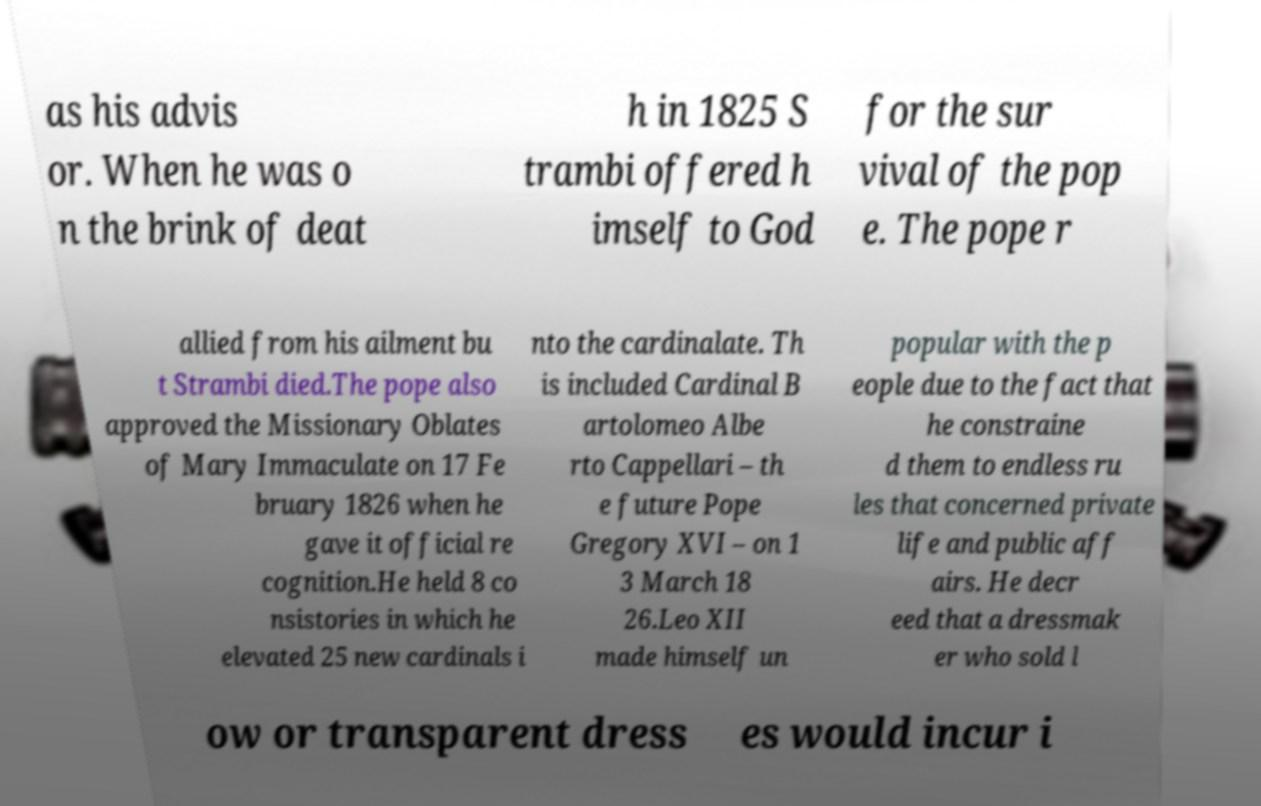Can you read and provide the text displayed in the image?This photo seems to have some interesting text. Can you extract and type it out for me? as his advis or. When he was o n the brink of deat h in 1825 S trambi offered h imself to God for the sur vival of the pop e. The pope r allied from his ailment bu t Strambi died.The pope also approved the Missionary Oblates of Mary Immaculate on 17 Fe bruary 1826 when he gave it official re cognition.He held 8 co nsistories in which he elevated 25 new cardinals i nto the cardinalate. Th is included Cardinal B artolomeo Albe rto Cappellari – th e future Pope Gregory XVI – on 1 3 March 18 26.Leo XII made himself un popular with the p eople due to the fact that he constraine d them to endless ru les that concerned private life and public aff airs. He decr eed that a dressmak er who sold l ow or transparent dress es would incur i 